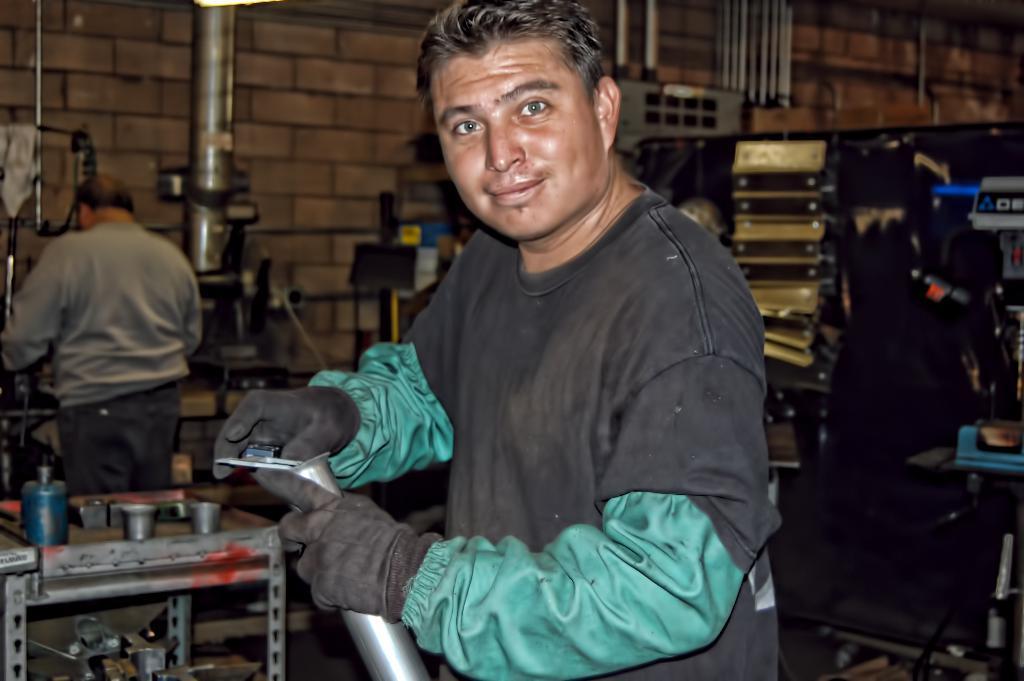How would you summarize this image in a sentence or two? This is an inside view. Here I can see a man standing, holding a metal object in the hand and looking at the picture. On the left side there is a table on which few objects are placed, behind there is another man standing facing towards the back side. In the background there are many metal objects and also I can see the wall. 